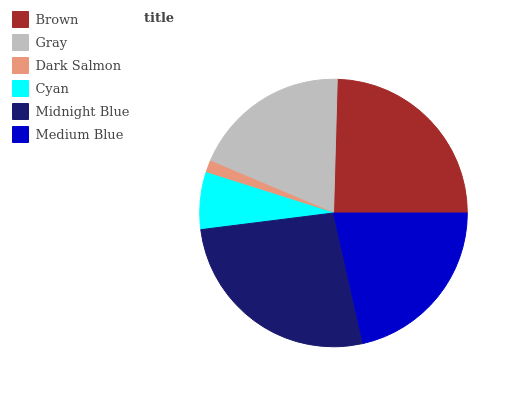Is Dark Salmon the minimum?
Answer yes or no. Yes. Is Midnight Blue the maximum?
Answer yes or no. Yes. Is Gray the minimum?
Answer yes or no. No. Is Gray the maximum?
Answer yes or no. No. Is Brown greater than Gray?
Answer yes or no. Yes. Is Gray less than Brown?
Answer yes or no. Yes. Is Gray greater than Brown?
Answer yes or no. No. Is Brown less than Gray?
Answer yes or no. No. Is Medium Blue the high median?
Answer yes or no. Yes. Is Gray the low median?
Answer yes or no. Yes. Is Cyan the high median?
Answer yes or no. No. Is Cyan the low median?
Answer yes or no. No. 